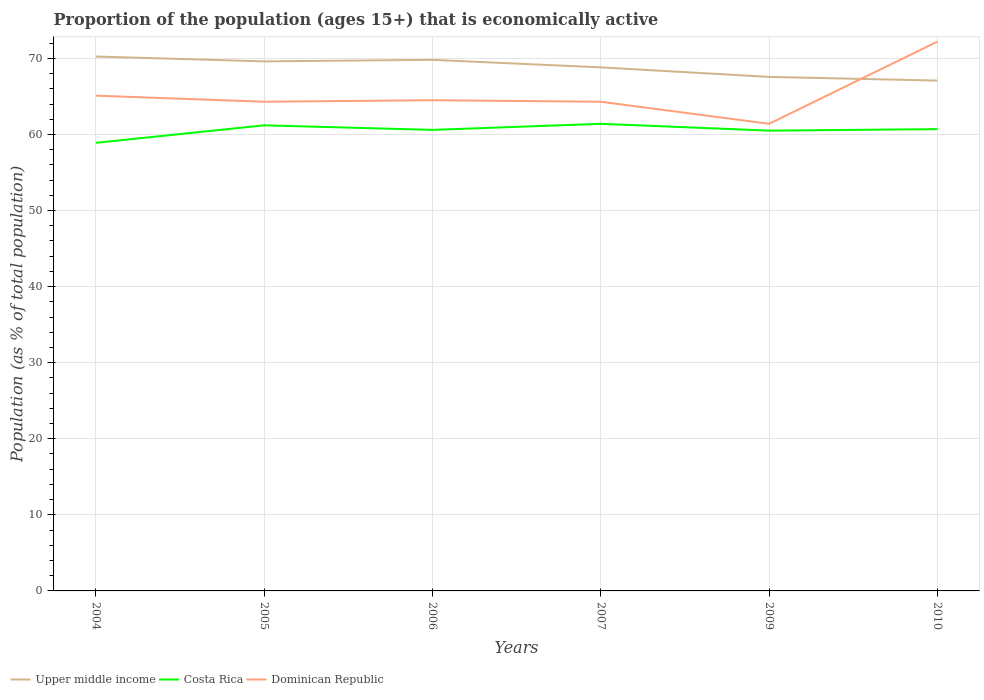Is the number of lines equal to the number of legend labels?
Provide a short and direct response. Yes. Across all years, what is the maximum proportion of the population that is economically active in Upper middle income?
Make the answer very short. 67.08. In which year was the proportion of the population that is economically active in Upper middle income maximum?
Provide a succinct answer. 2010. What is the total proportion of the population that is economically active in Upper middle income in the graph?
Provide a succinct answer. 0.64. What is the difference between the highest and the second highest proportion of the population that is economically active in Dominican Republic?
Provide a short and direct response. 10.8. What is the difference between the highest and the lowest proportion of the population that is economically active in Dominican Republic?
Give a very brief answer. 1. How many years are there in the graph?
Offer a terse response. 6. Are the values on the major ticks of Y-axis written in scientific E-notation?
Your response must be concise. No. Does the graph contain grids?
Offer a terse response. Yes. Where does the legend appear in the graph?
Keep it short and to the point. Bottom left. How many legend labels are there?
Keep it short and to the point. 3. How are the legend labels stacked?
Offer a very short reply. Horizontal. What is the title of the graph?
Your answer should be very brief. Proportion of the population (ages 15+) that is economically active. What is the label or title of the X-axis?
Keep it short and to the point. Years. What is the label or title of the Y-axis?
Your answer should be very brief. Population (as % of total population). What is the Population (as % of total population) of Upper middle income in 2004?
Your answer should be compact. 70.24. What is the Population (as % of total population) in Costa Rica in 2004?
Provide a succinct answer. 58.9. What is the Population (as % of total population) of Dominican Republic in 2004?
Make the answer very short. 65.1. What is the Population (as % of total population) in Upper middle income in 2005?
Make the answer very short. 69.6. What is the Population (as % of total population) in Costa Rica in 2005?
Your response must be concise. 61.2. What is the Population (as % of total population) of Dominican Republic in 2005?
Offer a very short reply. 64.3. What is the Population (as % of total population) of Upper middle income in 2006?
Give a very brief answer. 69.81. What is the Population (as % of total population) in Costa Rica in 2006?
Provide a succinct answer. 60.6. What is the Population (as % of total population) in Dominican Republic in 2006?
Make the answer very short. 64.5. What is the Population (as % of total population) of Upper middle income in 2007?
Give a very brief answer. 68.82. What is the Population (as % of total population) in Costa Rica in 2007?
Give a very brief answer. 61.4. What is the Population (as % of total population) of Dominican Republic in 2007?
Give a very brief answer. 64.3. What is the Population (as % of total population) in Upper middle income in 2009?
Ensure brevity in your answer.  67.57. What is the Population (as % of total population) of Costa Rica in 2009?
Your answer should be compact. 60.5. What is the Population (as % of total population) of Dominican Republic in 2009?
Your response must be concise. 61.4. What is the Population (as % of total population) in Upper middle income in 2010?
Keep it short and to the point. 67.08. What is the Population (as % of total population) of Costa Rica in 2010?
Give a very brief answer. 60.7. What is the Population (as % of total population) in Dominican Republic in 2010?
Your answer should be very brief. 72.2. Across all years, what is the maximum Population (as % of total population) of Upper middle income?
Your answer should be very brief. 70.24. Across all years, what is the maximum Population (as % of total population) of Costa Rica?
Ensure brevity in your answer.  61.4. Across all years, what is the maximum Population (as % of total population) of Dominican Republic?
Your response must be concise. 72.2. Across all years, what is the minimum Population (as % of total population) in Upper middle income?
Offer a very short reply. 67.08. Across all years, what is the minimum Population (as % of total population) of Costa Rica?
Ensure brevity in your answer.  58.9. Across all years, what is the minimum Population (as % of total population) in Dominican Republic?
Offer a very short reply. 61.4. What is the total Population (as % of total population) of Upper middle income in the graph?
Provide a short and direct response. 413.11. What is the total Population (as % of total population) of Costa Rica in the graph?
Make the answer very short. 363.3. What is the total Population (as % of total population) in Dominican Republic in the graph?
Ensure brevity in your answer.  391.8. What is the difference between the Population (as % of total population) of Upper middle income in 2004 and that in 2005?
Provide a succinct answer. 0.64. What is the difference between the Population (as % of total population) of Costa Rica in 2004 and that in 2005?
Offer a very short reply. -2.3. What is the difference between the Population (as % of total population) in Dominican Republic in 2004 and that in 2005?
Offer a very short reply. 0.8. What is the difference between the Population (as % of total population) in Upper middle income in 2004 and that in 2006?
Provide a short and direct response. 0.44. What is the difference between the Population (as % of total population) in Costa Rica in 2004 and that in 2006?
Ensure brevity in your answer.  -1.7. What is the difference between the Population (as % of total population) in Dominican Republic in 2004 and that in 2006?
Offer a terse response. 0.6. What is the difference between the Population (as % of total population) in Upper middle income in 2004 and that in 2007?
Keep it short and to the point. 1.43. What is the difference between the Population (as % of total population) of Dominican Republic in 2004 and that in 2007?
Provide a short and direct response. 0.8. What is the difference between the Population (as % of total population) in Upper middle income in 2004 and that in 2009?
Give a very brief answer. 2.68. What is the difference between the Population (as % of total population) of Costa Rica in 2004 and that in 2009?
Your response must be concise. -1.6. What is the difference between the Population (as % of total population) of Dominican Republic in 2004 and that in 2009?
Your answer should be compact. 3.7. What is the difference between the Population (as % of total population) of Upper middle income in 2004 and that in 2010?
Provide a succinct answer. 3.17. What is the difference between the Population (as % of total population) in Costa Rica in 2004 and that in 2010?
Keep it short and to the point. -1.8. What is the difference between the Population (as % of total population) of Dominican Republic in 2004 and that in 2010?
Keep it short and to the point. -7.1. What is the difference between the Population (as % of total population) of Upper middle income in 2005 and that in 2006?
Provide a short and direct response. -0.2. What is the difference between the Population (as % of total population) of Costa Rica in 2005 and that in 2006?
Provide a succinct answer. 0.6. What is the difference between the Population (as % of total population) of Upper middle income in 2005 and that in 2007?
Offer a terse response. 0.79. What is the difference between the Population (as % of total population) in Dominican Republic in 2005 and that in 2007?
Provide a short and direct response. 0. What is the difference between the Population (as % of total population) of Upper middle income in 2005 and that in 2009?
Your answer should be compact. 2.04. What is the difference between the Population (as % of total population) in Dominican Republic in 2005 and that in 2009?
Your answer should be very brief. 2.9. What is the difference between the Population (as % of total population) of Upper middle income in 2005 and that in 2010?
Keep it short and to the point. 2.52. What is the difference between the Population (as % of total population) in Dominican Republic in 2005 and that in 2010?
Give a very brief answer. -7.9. What is the difference between the Population (as % of total population) in Upper middle income in 2006 and that in 2007?
Your response must be concise. 0.99. What is the difference between the Population (as % of total population) in Upper middle income in 2006 and that in 2009?
Provide a succinct answer. 2.24. What is the difference between the Population (as % of total population) of Costa Rica in 2006 and that in 2009?
Offer a very short reply. 0.1. What is the difference between the Population (as % of total population) in Dominican Republic in 2006 and that in 2009?
Ensure brevity in your answer.  3.1. What is the difference between the Population (as % of total population) in Upper middle income in 2006 and that in 2010?
Offer a very short reply. 2.73. What is the difference between the Population (as % of total population) of Costa Rica in 2006 and that in 2010?
Give a very brief answer. -0.1. What is the difference between the Population (as % of total population) in Dominican Republic in 2006 and that in 2010?
Make the answer very short. -7.7. What is the difference between the Population (as % of total population) of Upper middle income in 2007 and that in 2009?
Your answer should be very brief. 1.25. What is the difference between the Population (as % of total population) of Costa Rica in 2007 and that in 2009?
Your answer should be very brief. 0.9. What is the difference between the Population (as % of total population) in Dominican Republic in 2007 and that in 2009?
Your response must be concise. 2.9. What is the difference between the Population (as % of total population) in Upper middle income in 2007 and that in 2010?
Make the answer very short. 1.74. What is the difference between the Population (as % of total population) in Dominican Republic in 2007 and that in 2010?
Your answer should be very brief. -7.9. What is the difference between the Population (as % of total population) in Upper middle income in 2009 and that in 2010?
Offer a terse response. 0.49. What is the difference between the Population (as % of total population) in Upper middle income in 2004 and the Population (as % of total population) in Costa Rica in 2005?
Your response must be concise. 9.04. What is the difference between the Population (as % of total population) in Upper middle income in 2004 and the Population (as % of total population) in Dominican Republic in 2005?
Offer a very short reply. 5.94. What is the difference between the Population (as % of total population) of Upper middle income in 2004 and the Population (as % of total population) of Costa Rica in 2006?
Offer a terse response. 9.64. What is the difference between the Population (as % of total population) of Upper middle income in 2004 and the Population (as % of total population) of Dominican Republic in 2006?
Offer a terse response. 5.74. What is the difference between the Population (as % of total population) in Upper middle income in 2004 and the Population (as % of total population) in Costa Rica in 2007?
Provide a succinct answer. 8.84. What is the difference between the Population (as % of total population) of Upper middle income in 2004 and the Population (as % of total population) of Dominican Republic in 2007?
Your answer should be very brief. 5.94. What is the difference between the Population (as % of total population) of Costa Rica in 2004 and the Population (as % of total population) of Dominican Republic in 2007?
Offer a terse response. -5.4. What is the difference between the Population (as % of total population) of Upper middle income in 2004 and the Population (as % of total population) of Costa Rica in 2009?
Keep it short and to the point. 9.74. What is the difference between the Population (as % of total population) of Upper middle income in 2004 and the Population (as % of total population) of Dominican Republic in 2009?
Your answer should be compact. 8.84. What is the difference between the Population (as % of total population) in Upper middle income in 2004 and the Population (as % of total population) in Costa Rica in 2010?
Keep it short and to the point. 9.54. What is the difference between the Population (as % of total population) of Upper middle income in 2004 and the Population (as % of total population) of Dominican Republic in 2010?
Provide a succinct answer. -1.96. What is the difference between the Population (as % of total population) of Costa Rica in 2004 and the Population (as % of total population) of Dominican Republic in 2010?
Your answer should be very brief. -13.3. What is the difference between the Population (as % of total population) in Upper middle income in 2005 and the Population (as % of total population) in Costa Rica in 2006?
Your answer should be compact. 9. What is the difference between the Population (as % of total population) in Upper middle income in 2005 and the Population (as % of total population) in Dominican Republic in 2006?
Offer a terse response. 5.1. What is the difference between the Population (as % of total population) of Upper middle income in 2005 and the Population (as % of total population) of Costa Rica in 2007?
Give a very brief answer. 8.2. What is the difference between the Population (as % of total population) of Upper middle income in 2005 and the Population (as % of total population) of Dominican Republic in 2007?
Make the answer very short. 5.3. What is the difference between the Population (as % of total population) in Upper middle income in 2005 and the Population (as % of total population) in Costa Rica in 2009?
Your response must be concise. 9.1. What is the difference between the Population (as % of total population) of Upper middle income in 2005 and the Population (as % of total population) of Dominican Republic in 2009?
Provide a short and direct response. 8.2. What is the difference between the Population (as % of total population) of Upper middle income in 2005 and the Population (as % of total population) of Costa Rica in 2010?
Your answer should be very brief. 8.9. What is the difference between the Population (as % of total population) of Upper middle income in 2005 and the Population (as % of total population) of Dominican Republic in 2010?
Provide a succinct answer. -2.6. What is the difference between the Population (as % of total population) in Costa Rica in 2005 and the Population (as % of total population) in Dominican Republic in 2010?
Give a very brief answer. -11. What is the difference between the Population (as % of total population) of Upper middle income in 2006 and the Population (as % of total population) of Costa Rica in 2007?
Provide a succinct answer. 8.41. What is the difference between the Population (as % of total population) of Upper middle income in 2006 and the Population (as % of total population) of Dominican Republic in 2007?
Provide a short and direct response. 5.51. What is the difference between the Population (as % of total population) in Costa Rica in 2006 and the Population (as % of total population) in Dominican Republic in 2007?
Your answer should be compact. -3.7. What is the difference between the Population (as % of total population) of Upper middle income in 2006 and the Population (as % of total population) of Costa Rica in 2009?
Your answer should be very brief. 9.31. What is the difference between the Population (as % of total population) in Upper middle income in 2006 and the Population (as % of total population) in Dominican Republic in 2009?
Provide a succinct answer. 8.41. What is the difference between the Population (as % of total population) in Upper middle income in 2006 and the Population (as % of total population) in Costa Rica in 2010?
Provide a short and direct response. 9.11. What is the difference between the Population (as % of total population) in Upper middle income in 2006 and the Population (as % of total population) in Dominican Republic in 2010?
Your answer should be very brief. -2.39. What is the difference between the Population (as % of total population) in Upper middle income in 2007 and the Population (as % of total population) in Costa Rica in 2009?
Offer a terse response. 8.32. What is the difference between the Population (as % of total population) in Upper middle income in 2007 and the Population (as % of total population) in Dominican Republic in 2009?
Your answer should be very brief. 7.42. What is the difference between the Population (as % of total population) in Costa Rica in 2007 and the Population (as % of total population) in Dominican Republic in 2009?
Provide a short and direct response. 0. What is the difference between the Population (as % of total population) in Upper middle income in 2007 and the Population (as % of total population) in Costa Rica in 2010?
Provide a succinct answer. 8.12. What is the difference between the Population (as % of total population) of Upper middle income in 2007 and the Population (as % of total population) of Dominican Republic in 2010?
Make the answer very short. -3.38. What is the difference between the Population (as % of total population) of Upper middle income in 2009 and the Population (as % of total population) of Costa Rica in 2010?
Offer a terse response. 6.87. What is the difference between the Population (as % of total population) of Upper middle income in 2009 and the Population (as % of total population) of Dominican Republic in 2010?
Your answer should be very brief. -4.63. What is the difference between the Population (as % of total population) of Costa Rica in 2009 and the Population (as % of total population) of Dominican Republic in 2010?
Offer a very short reply. -11.7. What is the average Population (as % of total population) in Upper middle income per year?
Give a very brief answer. 68.85. What is the average Population (as % of total population) of Costa Rica per year?
Provide a succinct answer. 60.55. What is the average Population (as % of total population) in Dominican Republic per year?
Your response must be concise. 65.3. In the year 2004, what is the difference between the Population (as % of total population) in Upper middle income and Population (as % of total population) in Costa Rica?
Provide a succinct answer. 11.34. In the year 2004, what is the difference between the Population (as % of total population) of Upper middle income and Population (as % of total population) of Dominican Republic?
Provide a succinct answer. 5.14. In the year 2004, what is the difference between the Population (as % of total population) in Costa Rica and Population (as % of total population) in Dominican Republic?
Make the answer very short. -6.2. In the year 2005, what is the difference between the Population (as % of total population) in Upper middle income and Population (as % of total population) in Costa Rica?
Provide a short and direct response. 8.4. In the year 2005, what is the difference between the Population (as % of total population) in Upper middle income and Population (as % of total population) in Dominican Republic?
Provide a short and direct response. 5.3. In the year 2006, what is the difference between the Population (as % of total population) in Upper middle income and Population (as % of total population) in Costa Rica?
Provide a succinct answer. 9.21. In the year 2006, what is the difference between the Population (as % of total population) of Upper middle income and Population (as % of total population) of Dominican Republic?
Your response must be concise. 5.31. In the year 2006, what is the difference between the Population (as % of total population) in Costa Rica and Population (as % of total population) in Dominican Republic?
Make the answer very short. -3.9. In the year 2007, what is the difference between the Population (as % of total population) in Upper middle income and Population (as % of total population) in Costa Rica?
Offer a very short reply. 7.42. In the year 2007, what is the difference between the Population (as % of total population) in Upper middle income and Population (as % of total population) in Dominican Republic?
Offer a terse response. 4.52. In the year 2007, what is the difference between the Population (as % of total population) of Costa Rica and Population (as % of total population) of Dominican Republic?
Offer a very short reply. -2.9. In the year 2009, what is the difference between the Population (as % of total population) in Upper middle income and Population (as % of total population) in Costa Rica?
Your response must be concise. 7.07. In the year 2009, what is the difference between the Population (as % of total population) of Upper middle income and Population (as % of total population) of Dominican Republic?
Make the answer very short. 6.17. In the year 2009, what is the difference between the Population (as % of total population) in Costa Rica and Population (as % of total population) in Dominican Republic?
Offer a very short reply. -0.9. In the year 2010, what is the difference between the Population (as % of total population) of Upper middle income and Population (as % of total population) of Costa Rica?
Ensure brevity in your answer.  6.38. In the year 2010, what is the difference between the Population (as % of total population) in Upper middle income and Population (as % of total population) in Dominican Republic?
Keep it short and to the point. -5.12. What is the ratio of the Population (as % of total population) in Upper middle income in 2004 to that in 2005?
Offer a terse response. 1.01. What is the ratio of the Population (as % of total population) of Costa Rica in 2004 to that in 2005?
Keep it short and to the point. 0.96. What is the ratio of the Population (as % of total population) in Dominican Republic in 2004 to that in 2005?
Offer a terse response. 1.01. What is the ratio of the Population (as % of total population) in Costa Rica in 2004 to that in 2006?
Your answer should be compact. 0.97. What is the ratio of the Population (as % of total population) of Dominican Republic in 2004 to that in 2006?
Your response must be concise. 1.01. What is the ratio of the Population (as % of total population) of Upper middle income in 2004 to that in 2007?
Your response must be concise. 1.02. What is the ratio of the Population (as % of total population) of Costa Rica in 2004 to that in 2007?
Give a very brief answer. 0.96. What is the ratio of the Population (as % of total population) in Dominican Republic in 2004 to that in 2007?
Your answer should be compact. 1.01. What is the ratio of the Population (as % of total population) in Upper middle income in 2004 to that in 2009?
Your answer should be very brief. 1.04. What is the ratio of the Population (as % of total population) of Costa Rica in 2004 to that in 2009?
Your answer should be very brief. 0.97. What is the ratio of the Population (as % of total population) of Dominican Republic in 2004 to that in 2009?
Offer a terse response. 1.06. What is the ratio of the Population (as % of total population) of Upper middle income in 2004 to that in 2010?
Make the answer very short. 1.05. What is the ratio of the Population (as % of total population) of Costa Rica in 2004 to that in 2010?
Make the answer very short. 0.97. What is the ratio of the Population (as % of total population) in Dominican Republic in 2004 to that in 2010?
Your answer should be compact. 0.9. What is the ratio of the Population (as % of total population) of Costa Rica in 2005 to that in 2006?
Keep it short and to the point. 1.01. What is the ratio of the Population (as % of total population) of Dominican Republic in 2005 to that in 2006?
Ensure brevity in your answer.  1. What is the ratio of the Population (as % of total population) of Upper middle income in 2005 to that in 2007?
Keep it short and to the point. 1.01. What is the ratio of the Population (as % of total population) of Costa Rica in 2005 to that in 2007?
Offer a very short reply. 1. What is the ratio of the Population (as % of total population) in Upper middle income in 2005 to that in 2009?
Your answer should be compact. 1.03. What is the ratio of the Population (as % of total population) in Costa Rica in 2005 to that in 2009?
Offer a very short reply. 1.01. What is the ratio of the Population (as % of total population) of Dominican Republic in 2005 to that in 2009?
Offer a very short reply. 1.05. What is the ratio of the Population (as % of total population) of Upper middle income in 2005 to that in 2010?
Provide a short and direct response. 1.04. What is the ratio of the Population (as % of total population) of Costa Rica in 2005 to that in 2010?
Provide a short and direct response. 1.01. What is the ratio of the Population (as % of total population) of Dominican Republic in 2005 to that in 2010?
Provide a short and direct response. 0.89. What is the ratio of the Population (as % of total population) of Upper middle income in 2006 to that in 2007?
Offer a terse response. 1.01. What is the ratio of the Population (as % of total population) of Costa Rica in 2006 to that in 2007?
Offer a terse response. 0.99. What is the ratio of the Population (as % of total population) of Upper middle income in 2006 to that in 2009?
Offer a very short reply. 1.03. What is the ratio of the Population (as % of total population) of Costa Rica in 2006 to that in 2009?
Make the answer very short. 1. What is the ratio of the Population (as % of total population) in Dominican Republic in 2006 to that in 2009?
Offer a terse response. 1.05. What is the ratio of the Population (as % of total population) in Upper middle income in 2006 to that in 2010?
Offer a terse response. 1.04. What is the ratio of the Population (as % of total population) in Dominican Republic in 2006 to that in 2010?
Ensure brevity in your answer.  0.89. What is the ratio of the Population (as % of total population) in Upper middle income in 2007 to that in 2009?
Offer a terse response. 1.02. What is the ratio of the Population (as % of total population) of Costa Rica in 2007 to that in 2009?
Offer a terse response. 1.01. What is the ratio of the Population (as % of total population) in Dominican Republic in 2007 to that in 2009?
Your response must be concise. 1.05. What is the ratio of the Population (as % of total population) in Upper middle income in 2007 to that in 2010?
Keep it short and to the point. 1.03. What is the ratio of the Population (as % of total population) in Costa Rica in 2007 to that in 2010?
Provide a short and direct response. 1.01. What is the ratio of the Population (as % of total population) in Dominican Republic in 2007 to that in 2010?
Your response must be concise. 0.89. What is the ratio of the Population (as % of total population) in Upper middle income in 2009 to that in 2010?
Keep it short and to the point. 1.01. What is the ratio of the Population (as % of total population) of Costa Rica in 2009 to that in 2010?
Ensure brevity in your answer.  1. What is the ratio of the Population (as % of total population) of Dominican Republic in 2009 to that in 2010?
Make the answer very short. 0.85. What is the difference between the highest and the second highest Population (as % of total population) in Upper middle income?
Provide a short and direct response. 0.44. What is the difference between the highest and the second highest Population (as % of total population) in Dominican Republic?
Your answer should be very brief. 7.1. What is the difference between the highest and the lowest Population (as % of total population) in Upper middle income?
Your response must be concise. 3.17. What is the difference between the highest and the lowest Population (as % of total population) of Dominican Republic?
Give a very brief answer. 10.8. 